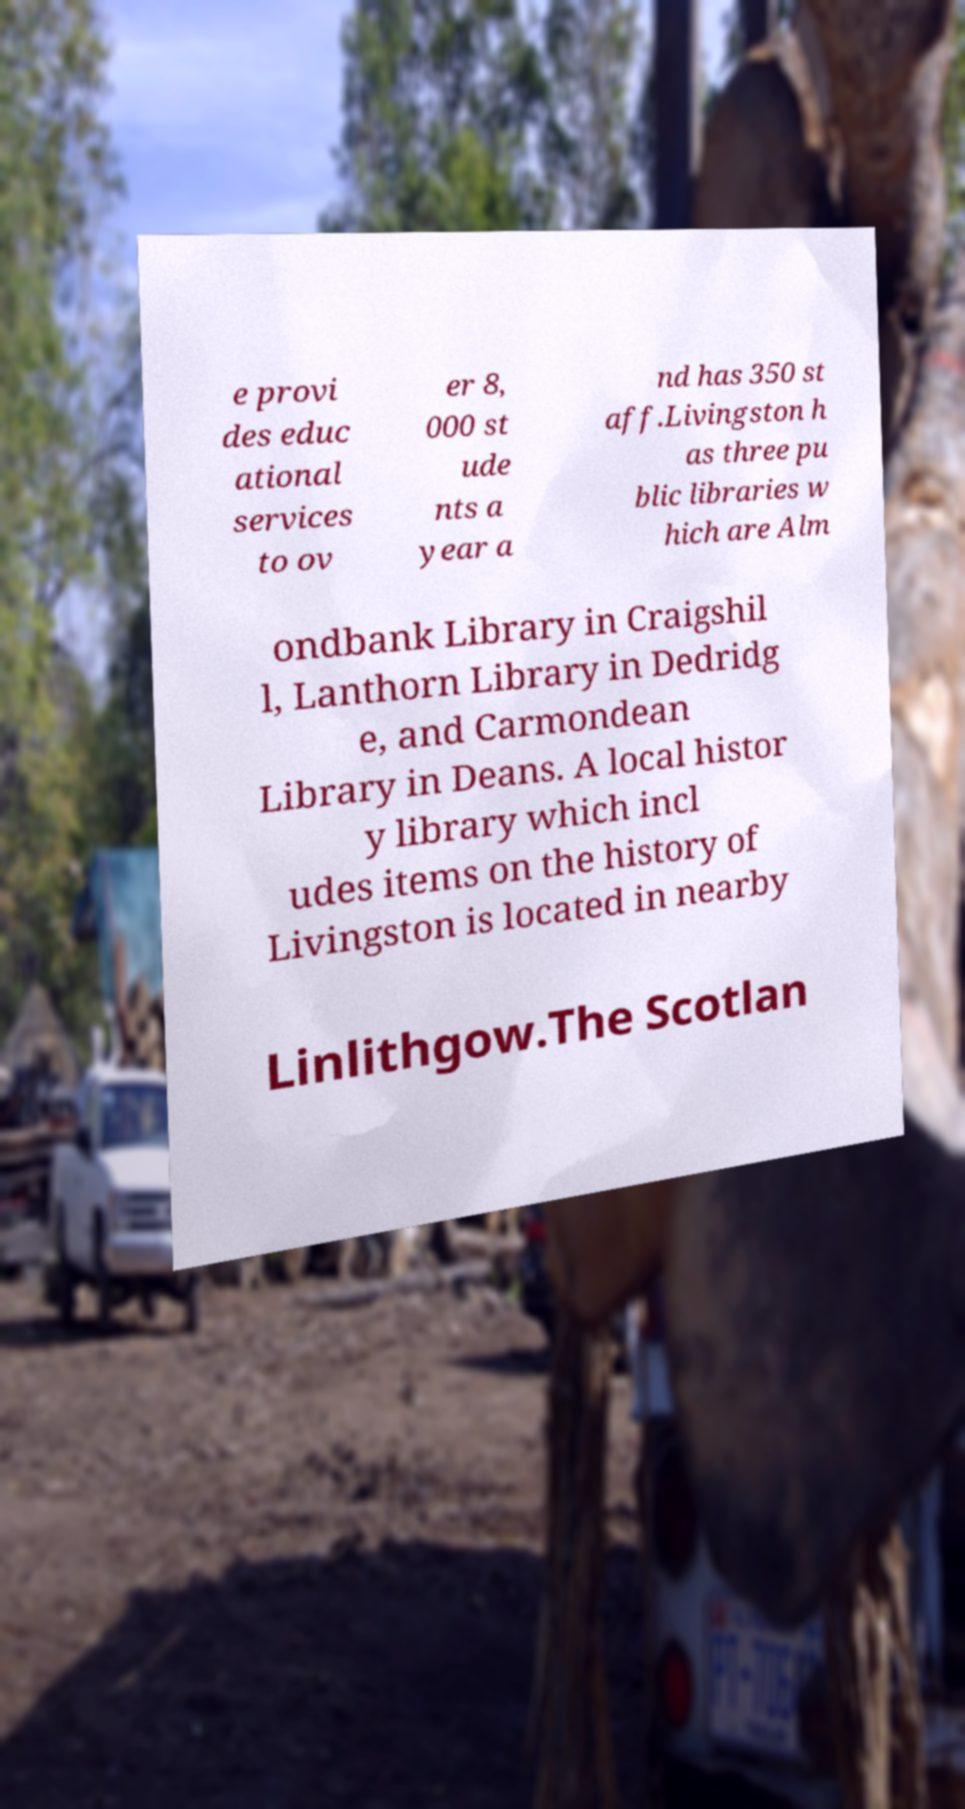There's text embedded in this image that I need extracted. Can you transcribe it verbatim? e provi des educ ational services to ov er 8, 000 st ude nts a year a nd has 350 st aff.Livingston h as three pu blic libraries w hich are Alm ondbank Library in Craigshil l, Lanthorn Library in Dedridg e, and Carmondean Library in Deans. A local histor y library which incl udes items on the history of Livingston is located in nearby Linlithgow.The Scotlan 